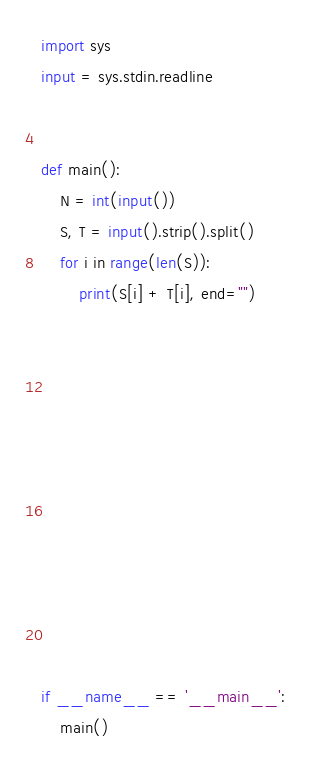Convert code to text. <code><loc_0><loc_0><loc_500><loc_500><_Python_>import sys
input = sys.stdin.readline


def main():
    N = int(input())
    S, T = input().strip().split()
    for i in range(len(S)):
        print(S[i] + T[i], end="")








    
    


if __name__ == '__main__':
    main()

</code> 